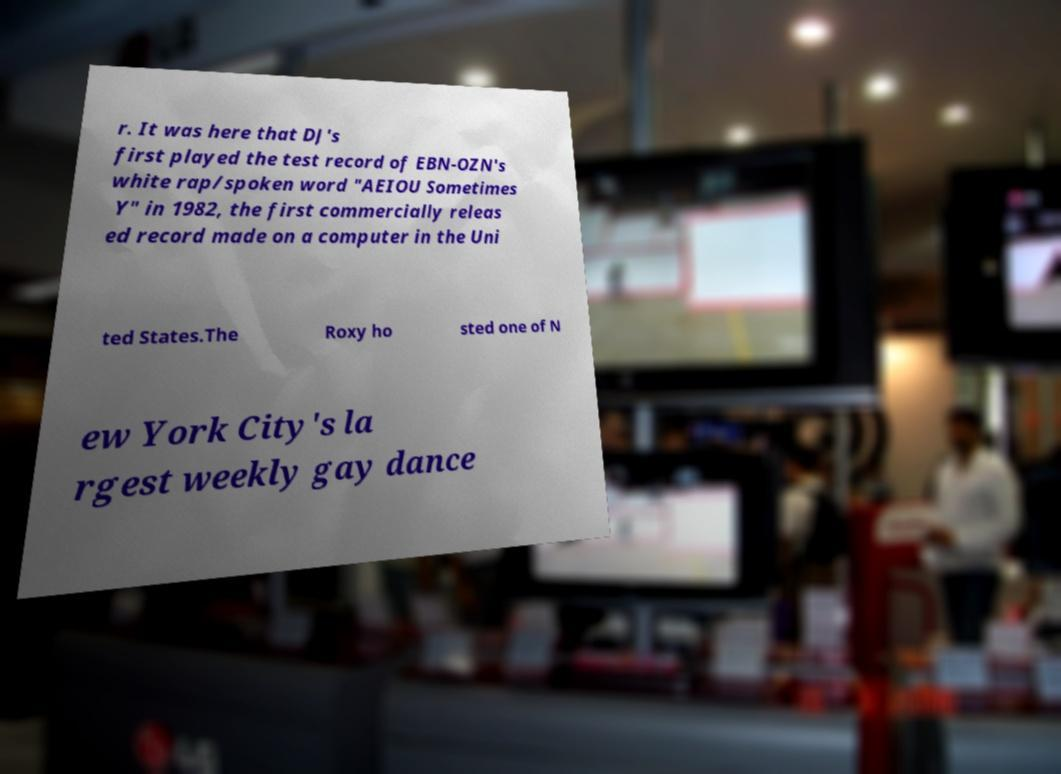There's text embedded in this image that I need extracted. Can you transcribe it verbatim? r. It was here that DJ's first played the test record of EBN-OZN's white rap/spoken word "AEIOU Sometimes Y" in 1982, the first commercially releas ed record made on a computer in the Uni ted States.The Roxy ho sted one of N ew York City's la rgest weekly gay dance 